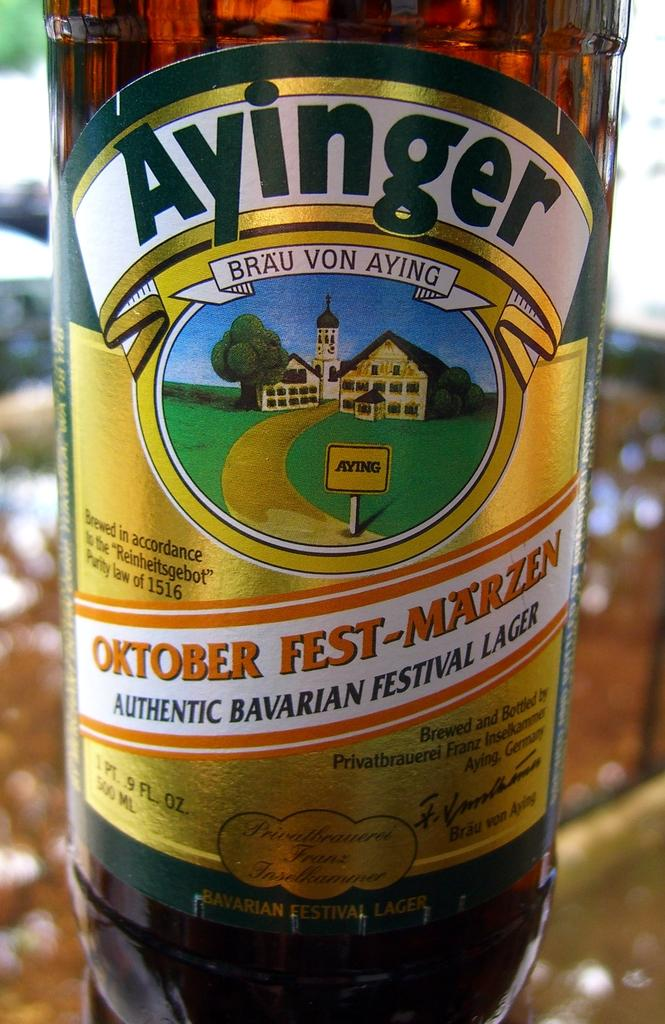<image>
Give a short and clear explanation of the subsequent image. a bottle of ayinger brau von aying oktober fest-marzen authentic bavarian festival lager 